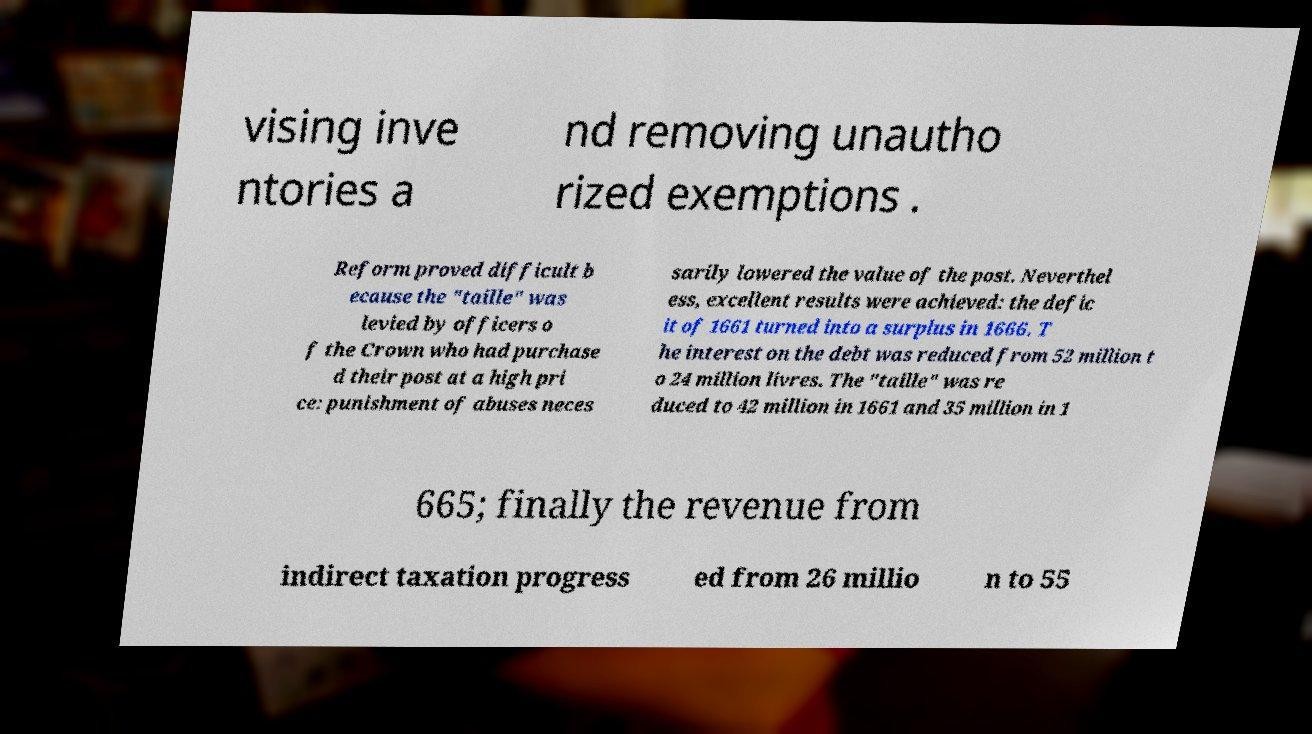Can you read and provide the text displayed in the image?This photo seems to have some interesting text. Can you extract and type it out for me? vising inve ntories a nd removing unautho rized exemptions . Reform proved difficult b ecause the "taille" was levied by officers o f the Crown who had purchase d their post at a high pri ce: punishment of abuses neces sarily lowered the value of the post. Neverthel ess, excellent results were achieved: the defic it of 1661 turned into a surplus in 1666. T he interest on the debt was reduced from 52 million t o 24 million livres. The "taille" was re duced to 42 million in 1661 and 35 million in 1 665; finally the revenue from indirect taxation progress ed from 26 millio n to 55 